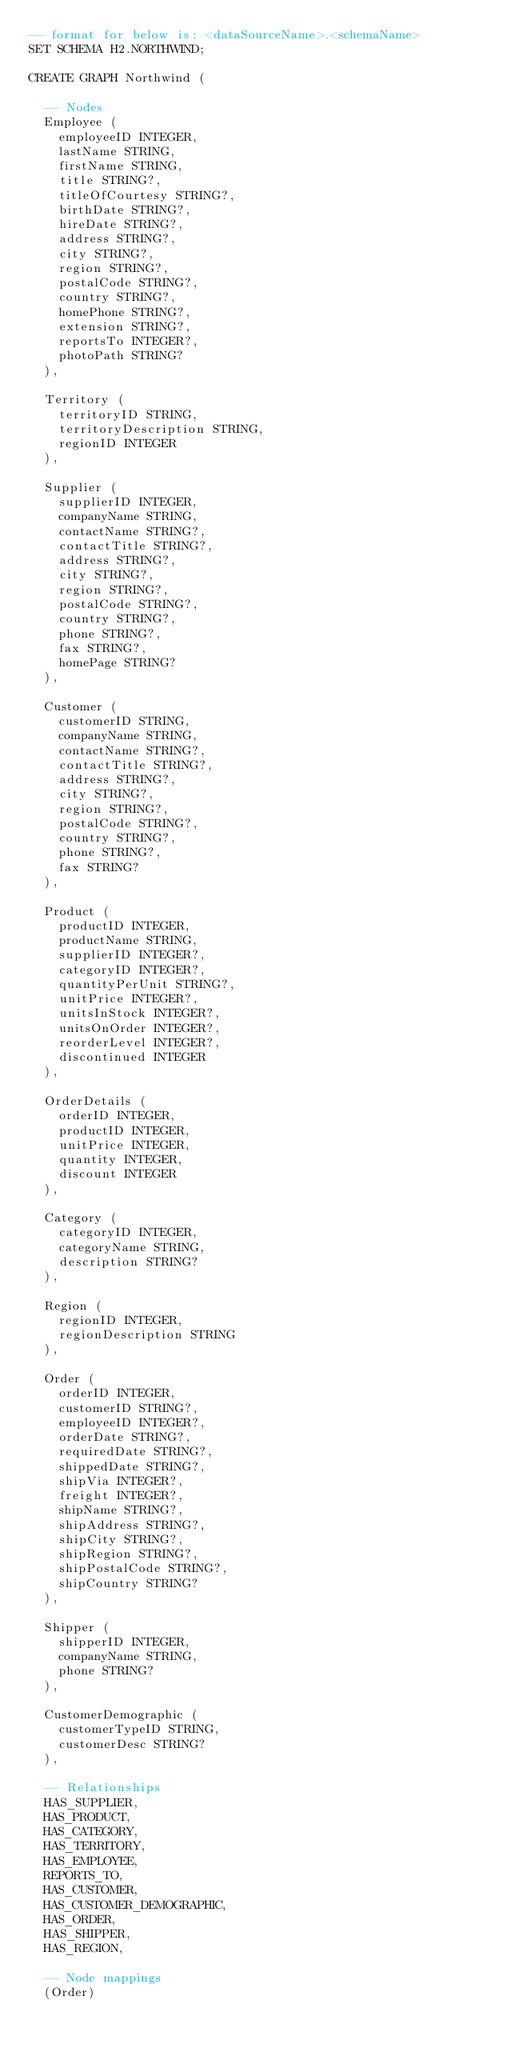Convert code to text. <code><loc_0><loc_0><loc_500><loc_500><_SQL_>-- format for below is: <dataSourceName>.<schemaName>
SET SCHEMA H2.NORTHWIND;

CREATE GRAPH Northwind (

  -- Nodes
  Employee (
    employeeID INTEGER,
    lastName STRING,
    firstName STRING,
    title STRING?,
    titleOfCourtesy STRING?,
    birthDate STRING?,
    hireDate STRING?,
    address STRING?,
    city STRING?,
    region STRING?,
    postalCode STRING?,
    country STRING?,
    homePhone STRING?,
    extension STRING?,
    reportsTo INTEGER?,
    photoPath STRING?
  ),

  Territory (
    territoryID STRING,
    territoryDescription STRING,
    regionID INTEGER
  ),

  Supplier (
    supplierID INTEGER,
    companyName STRING,
    contactName STRING?,
    contactTitle STRING?,
    address STRING?,
    city STRING?,
    region STRING?,
    postalCode STRING?,
    country STRING?,
    phone STRING?,
    fax STRING?,
    homePage STRING?
  ),

  Customer (
    customerID STRING,
    companyName STRING,
    contactName STRING?,
    contactTitle STRING?,
    address STRING?,
    city STRING?,
    region STRING?,
    postalCode STRING?,
    country STRING?,
    phone STRING?,
    fax STRING?
  ),

  Product (
    productID INTEGER,
    productName STRING,
    supplierID INTEGER?,
    categoryID INTEGER?,
    quantityPerUnit STRING?,
    unitPrice INTEGER?,
    unitsInStock INTEGER?,
    unitsOnOrder INTEGER?,
    reorderLevel INTEGER?,
    discontinued INTEGER
  ),

  OrderDetails (
    orderID INTEGER,
    productID INTEGER,
    unitPrice INTEGER,
    quantity INTEGER,
    discount INTEGER
  ),

  Category (
    categoryID INTEGER,
    categoryName STRING,
    description STRING?
  ),

  Region (
    regionID INTEGER,
    regionDescription STRING
  ),

  Order (
    orderID INTEGER,
    customerID STRING?,
    employeeID INTEGER?,
    orderDate STRING?,
    requiredDate STRING?,
    shippedDate STRING?,
    shipVia INTEGER?,
    freight INTEGER?,
    shipName STRING?,
    shipAddress STRING?,
    shipCity STRING?,
    shipRegion STRING?,
    shipPostalCode STRING?,
    shipCountry STRING?
  ),

  Shipper (
    shipperID INTEGER,
    companyName STRING,
    phone STRING?
  ),

  CustomerDemographic (
    customerTypeID STRING,
    customerDesc STRING?
  ),

  -- Relationships
  HAS_SUPPLIER,
  HAS_PRODUCT,
  HAS_CATEGORY,
  HAS_TERRITORY,
  HAS_EMPLOYEE,
  REPORTS_TO,
  HAS_CUSTOMER,
  HAS_CUSTOMER_DEMOGRAPHIC,
  HAS_ORDER,
  HAS_SHIPPER,
  HAS_REGION,

  -- Node mappings
  (Order)</code> 